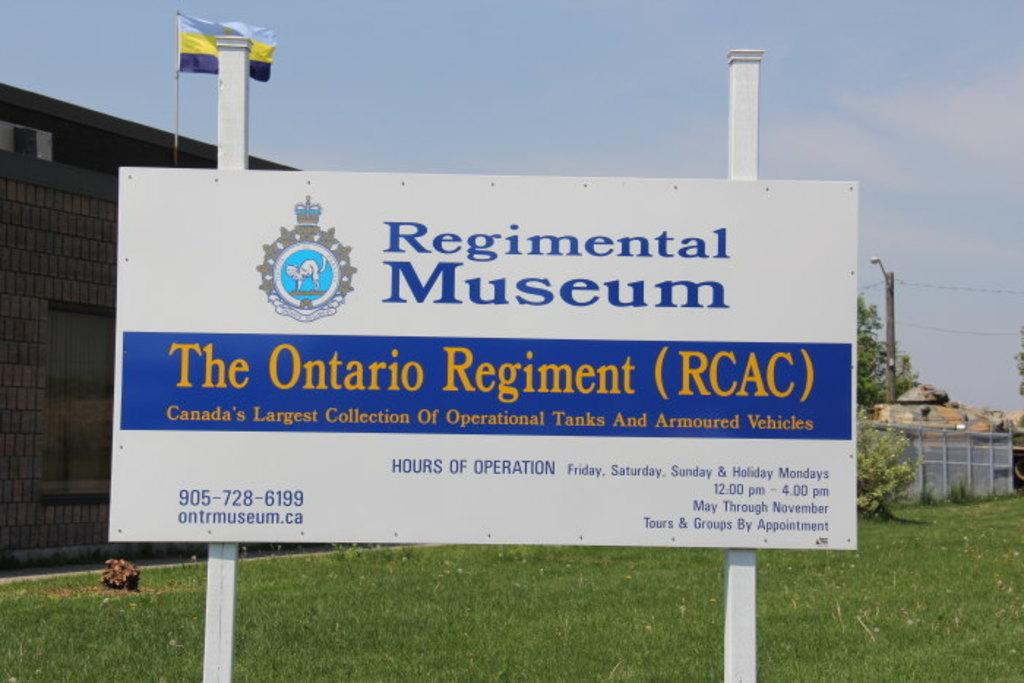<image>
Describe the image concisely. The image portrays a welcome sign for the Ontario Regiment's Regimental Museum. 